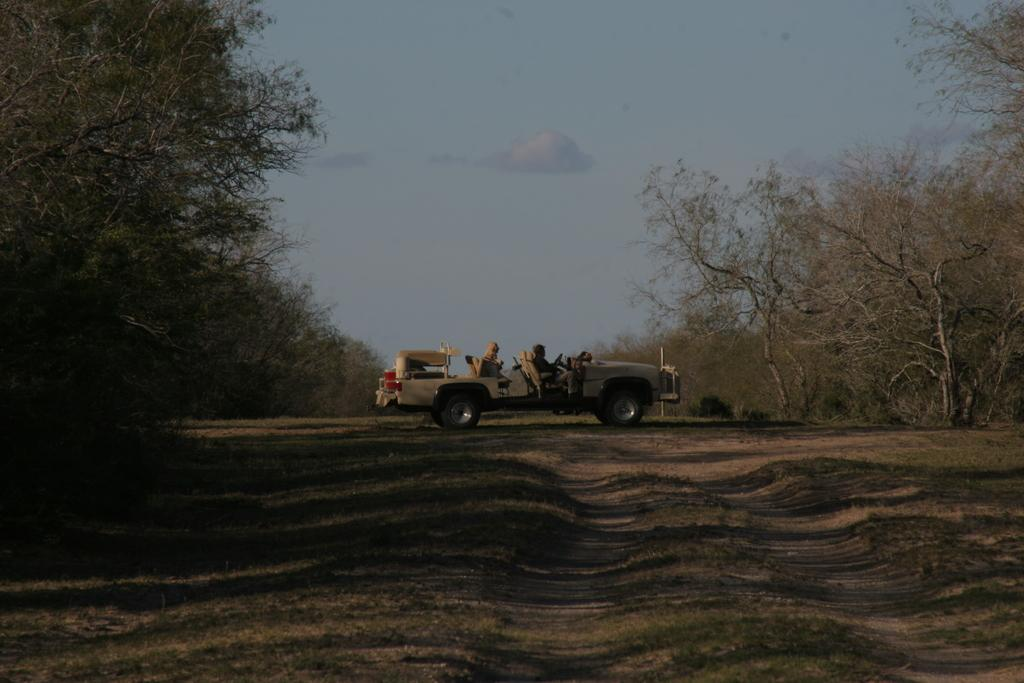What type of vehicle is in the image? There is a van in the image. Where is the van located? The van is in a forest. What can be seen in the background of the image? There are dry trees in the background of the image. What is the surface on which the van is standing? There is a ground visible in the image. What type of property does the van owner have in the image? There is no information about the van owner's property in the image. How much profit can be made from the van in the image? There is no information about the van's profitability in the image. 